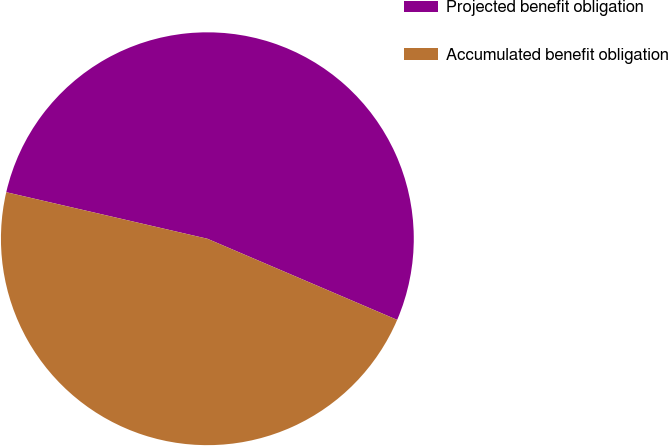Convert chart to OTSL. <chart><loc_0><loc_0><loc_500><loc_500><pie_chart><fcel>Projected benefit obligation<fcel>Accumulated benefit obligation<nl><fcel>52.81%<fcel>47.19%<nl></chart> 